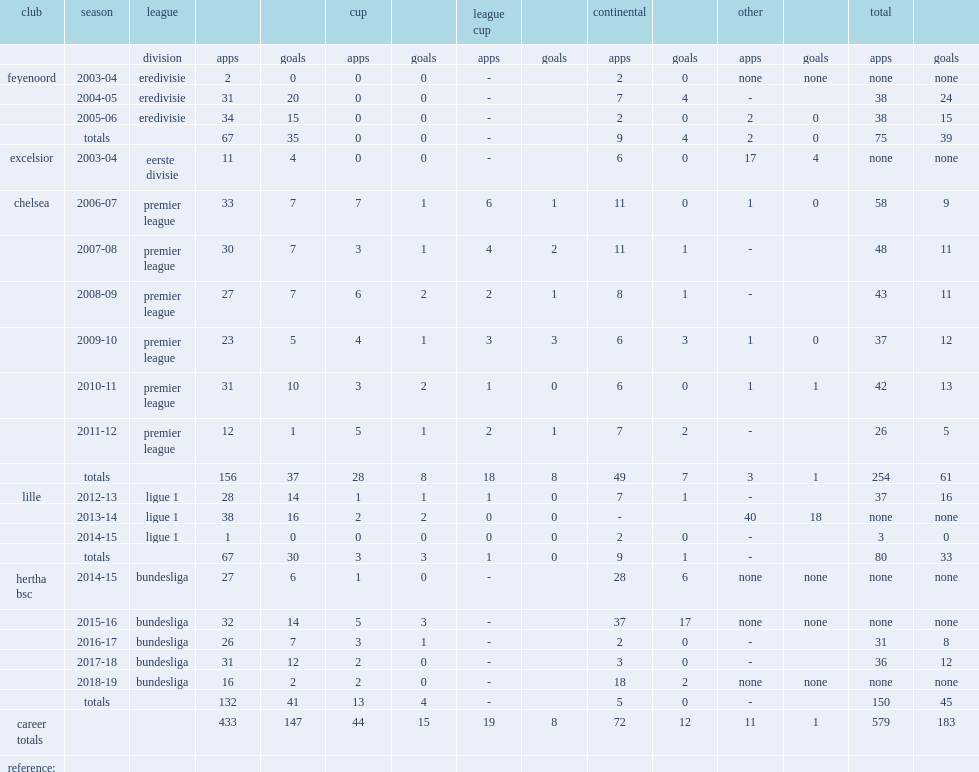How many games did salomon kalou play for chelsea in total? 254.0. 